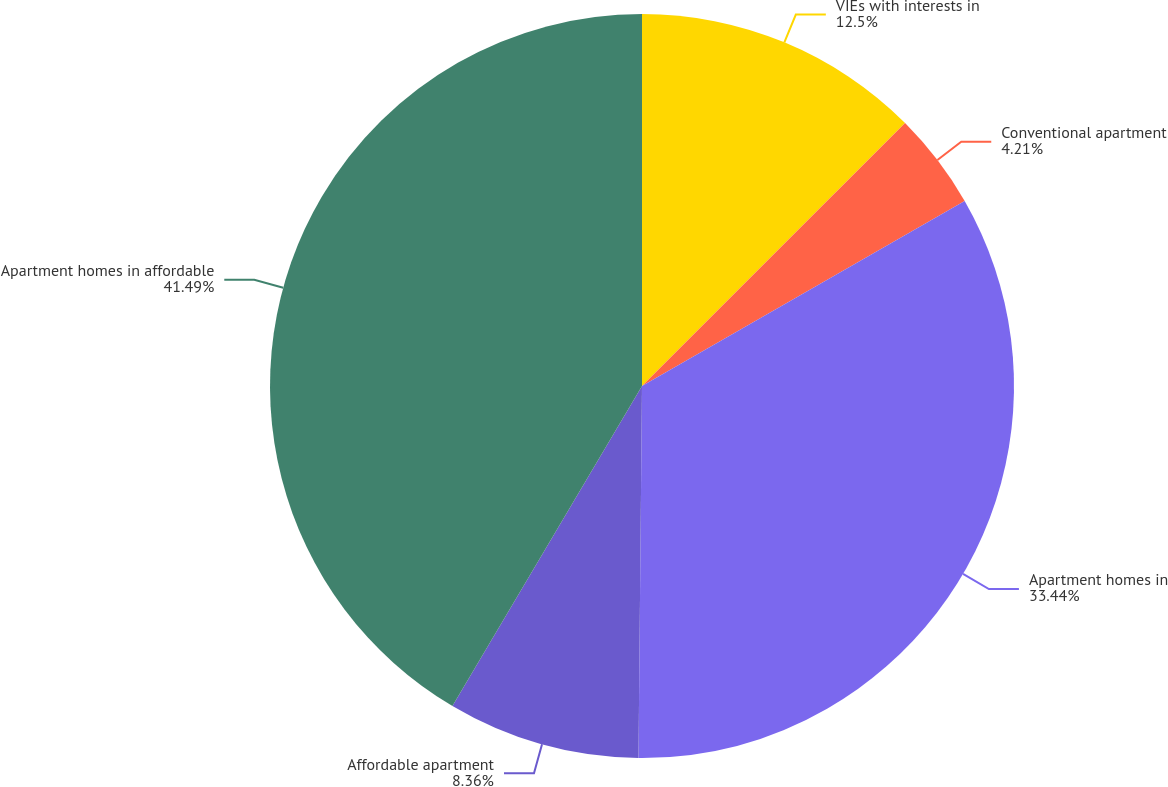Convert chart to OTSL. <chart><loc_0><loc_0><loc_500><loc_500><pie_chart><fcel>VIEs with interests in<fcel>Conventional apartment<fcel>Apartment homes in<fcel>Affordable apartment<fcel>Apartment homes in affordable<nl><fcel>12.5%<fcel>4.21%<fcel>33.44%<fcel>8.36%<fcel>41.49%<nl></chart> 